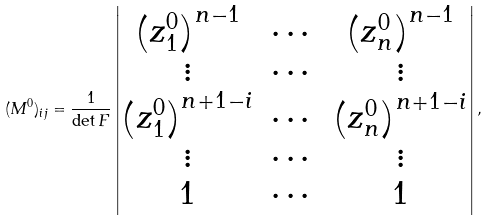<formula> <loc_0><loc_0><loc_500><loc_500>( M ^ { 0 } ) _ { i j } = \frac { 1 } { \det F } \begin{vmatrix} \left ( z _ { 1 } ^ { 0 } \right ) ^ { n - 1 } & \cdots & \left ( z _ { n } ^ { 0 } \right ) ^ { n - 1 } \\ \vdots & \cdots & \vdots \\ \left ( z _ { 1 } ^ { 0 } \right ) ^ { n + 1 - i } & \cdots & \left ( z _ { n } ^ { 0 } \right ) ^ { n + 1 - i } \\ \vdots & \cdots & \vdots \\ 1 & \cdots & 1 \end{vmatrix} ,</formula> 